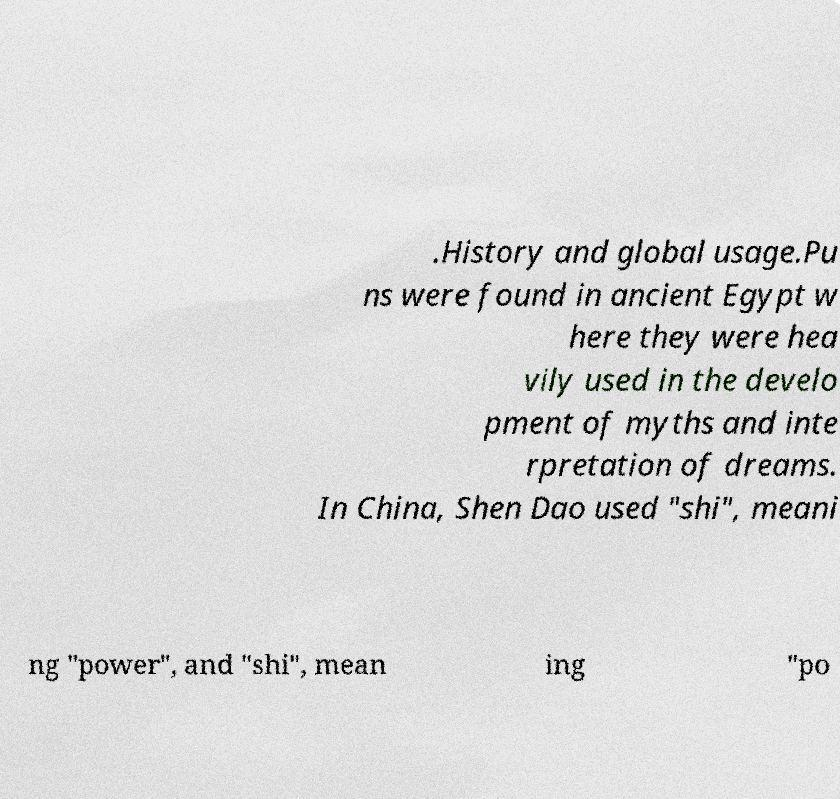I need the written content from this picture converted into text. Can you do that? .History and global usage.Pu ns were found in ancient Egypt w here they were hea vily used in the develo pment of myths and inte rpretation of dreams. In China, Shen Dao used "shi", meani ng "power", and "shi", mean ing "po 